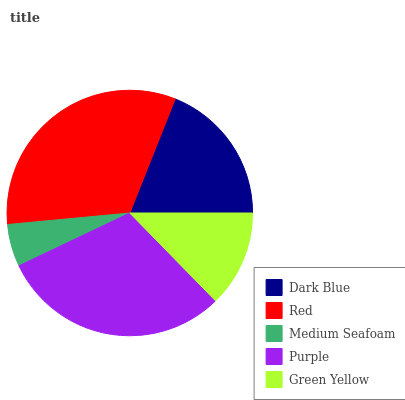Is Medium Seafoam the minimum?
Answer yes or no. Yes. Is Red the maximum?
Answer yes or no. Yes. Is Red the minimum?
Answer yes or no. No. Is Medium Seafoam the maximum?
Answer yes or no. No. Is Red greater than Medium Seafoam?
Answer yes or no. Yes. Is Medium Seafoam less than Red?
Answer yes or no. Yes. Is Medium Seafoam greater than Red?
Answer yes or no. No. Is Red less than Medium Seafoam?
Answer yes or no. No. Is Dark Blue the high median?
Answer yes or no. Yes. Is Dark Blue the low median?
Answer yes or no. Yes. Is Green Yellow the high median?
Answer yes or no. No. Is Purple the low median?
Answer yes or no. No. 